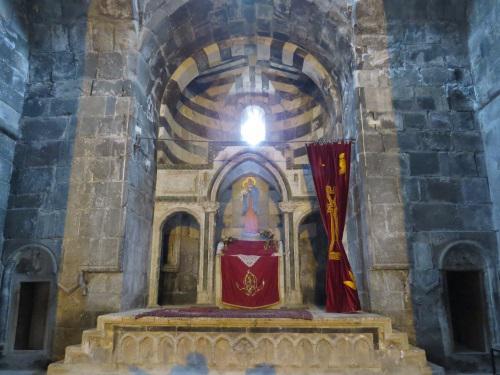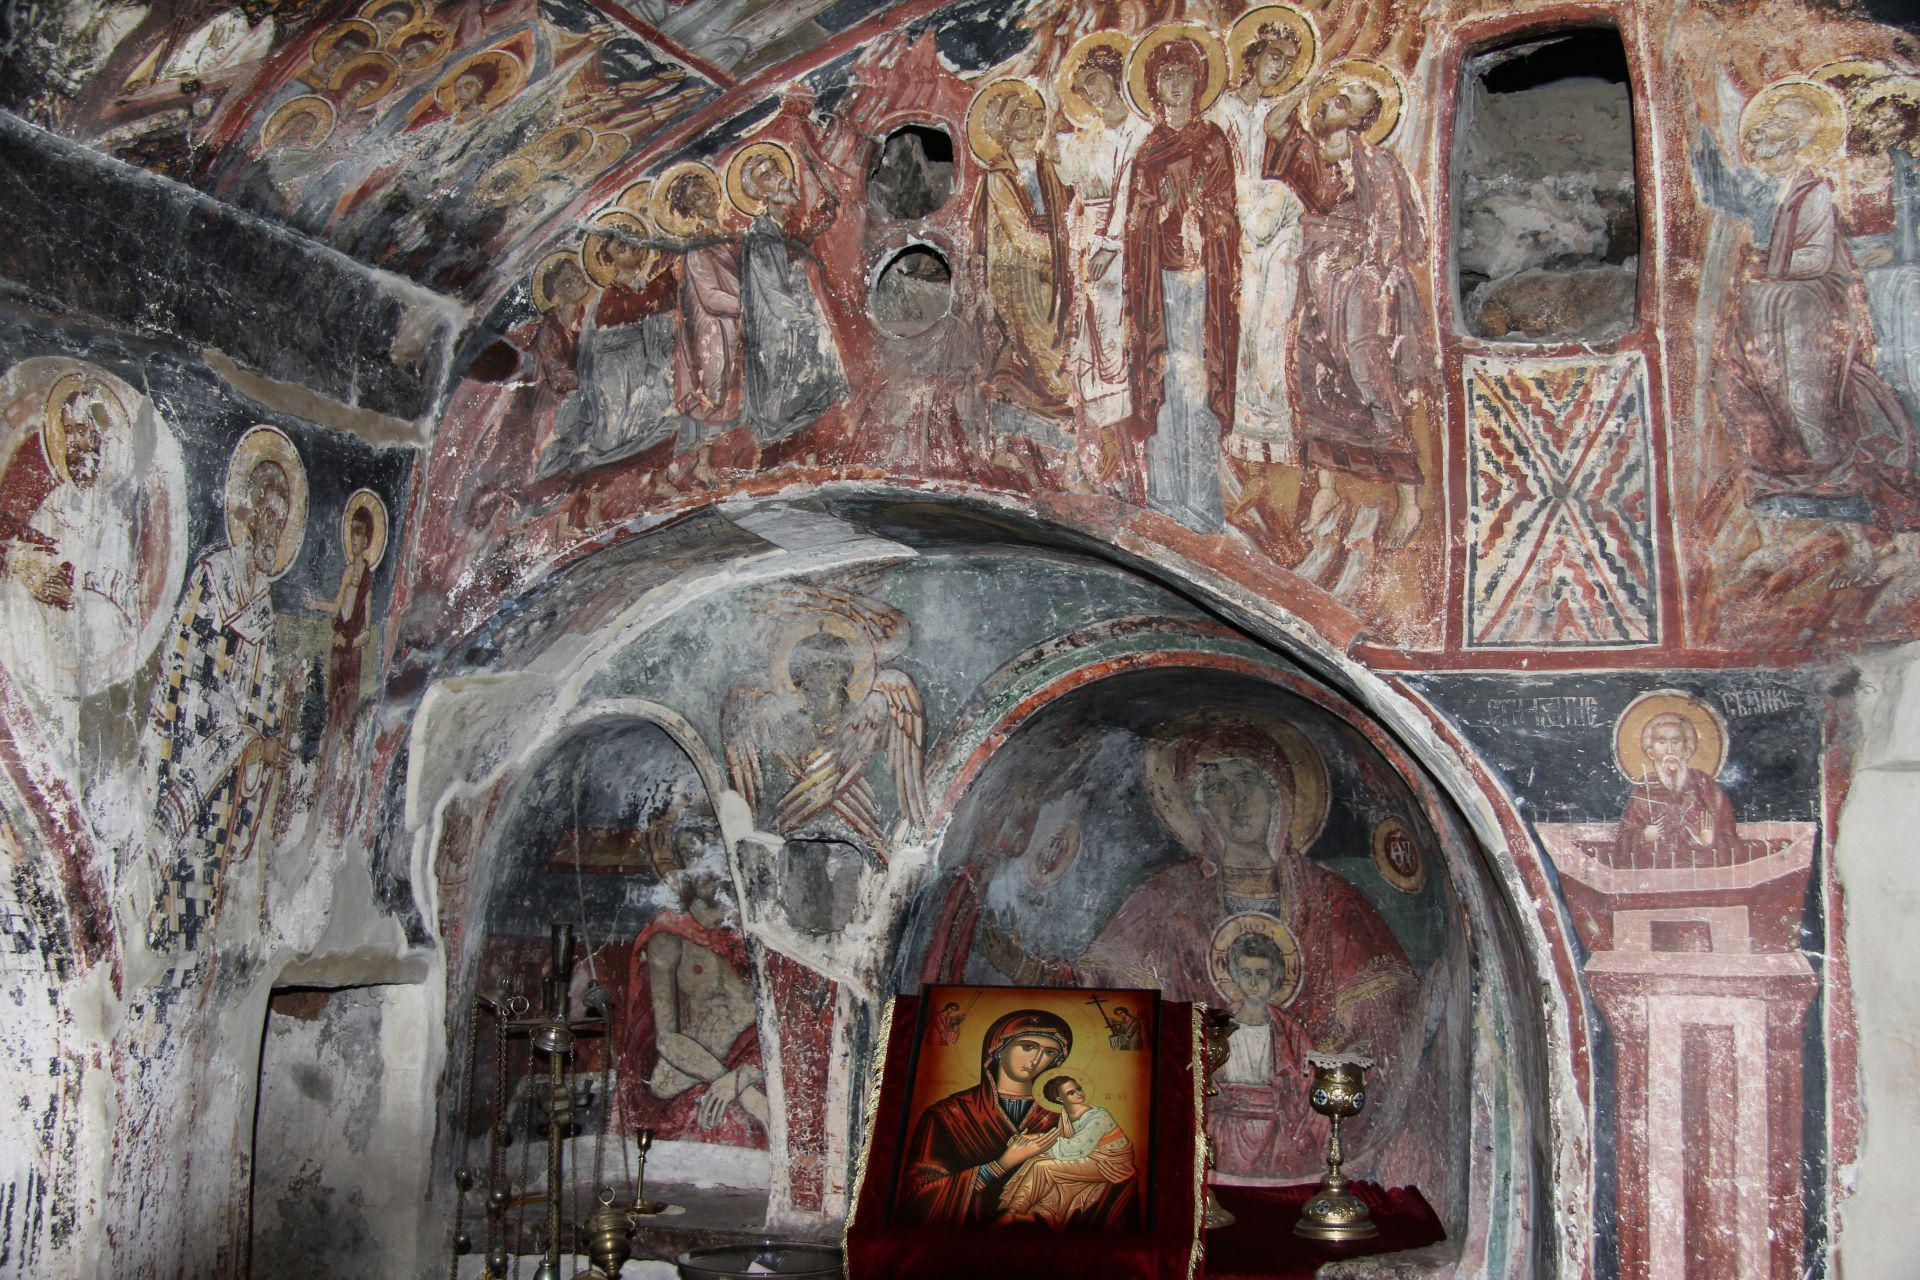The first image is the image on the left, the second image is the image on the right. Given the left and right images, does the statement "An image shows green lawn and a view of the outdoors through an archway." hold true? Answer yes or no. No. The first image is the image on the left, the second image is the image on the right. For the images displayed, is the sentence "A grassy outdoor area can be seen near the building in the image on the left." factually correct? Answer yes or no. No. 